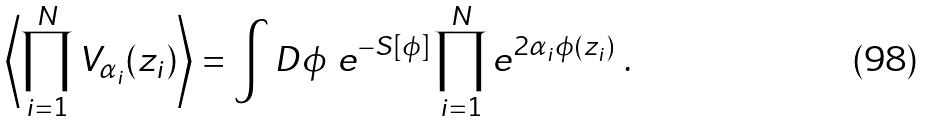Convert formula to latex. <formula><loc_0><loc_0><loc_500><loc_500>\left \langle \prod _ { i = 1 } ^ { N } V _ { \alpha _ { i } } ( z _ { i } ) \right \rangle = \int D \phi \ e ^ { - S [ \phi ] } \prod _ { i = 1 } ^ { N } e ^ { 2 \alpha _ { i } \phi ( z _ { i } ) } \ .</formula> 